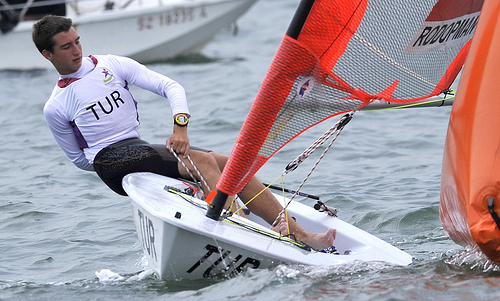<image>
Is the man on the boat? No. The man is not positioned on the boat. They may be near each other, but the man is not supported by or resting on top of the boat. 